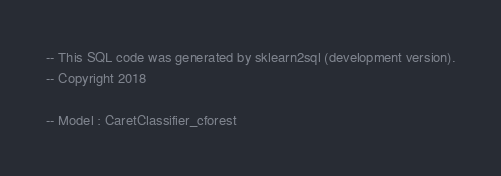Convert code to text. <code><loc_0><loc_0><loc_500><loc_500><_SQL_>-- This SQL code was generated by sklearn2sql (development version).
-- Copyright 2018

-- Model : CaretClassifier_cforest</code> 